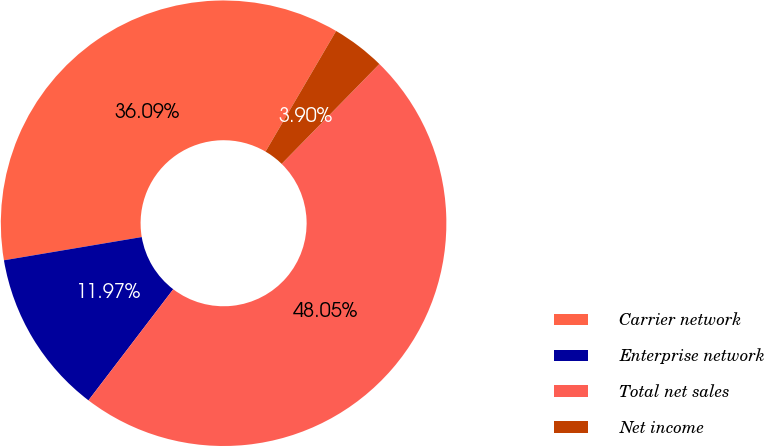Convert chart. <chart><loc_0><loc_0><loc_500><loc_500><pie_chart><fcel>Carrier network<fcel>Enterprise network<fcel>Total net sales<fcel>Net income<nl><fcel>36.09%<fcel>11.97%<fcel>48.05%<fcel>3.9%<nl></chart> 